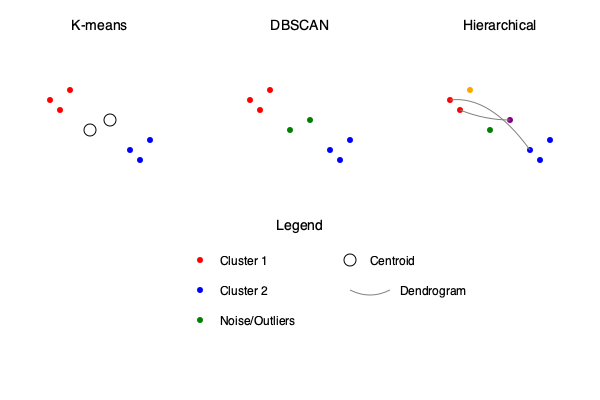Analyze the visual comparison of K-means, DBSCAN, and Hierarchical clustering algorithms on scattered data points. Which algorithm is most suitable for identifying clusters of arbitrary shape and handling noise in the dataset? To determine the most suitable algorithm for identifying clusters of arbitrary shape and handling noise, let's analyze each algorithm's characteristics based on the visual representation:

1. K-means:
   - Assumes spherical clusters
   - Sensitive to outliers
   - Requires predefined number of clusters
   - Centroids (black circles) are shown
   - Unable to identify noise points

2. DBSCAN (Density-Based Spatial Clustering of Applications with Noise):
   - Can identify clusters of arbitrary shape
   - Robust to outliers
   - Doesn't require predefined number of clusters
   - Identifies noise points (green)
   - Density-based approach

3. Hierarchical Clustering:
   - Can identify clusters of varying shapes
   - Sensitive to outliers
   - Doesn't require predefined number of clusters
   - Shows hierarchical structure (dendrogram)
   - May create small or singleton clusters

DBSCAN is the most suitable algorithm for identifying clusters of arbitrary shape and handling noise because:
1. It can detect clusters of any shape, not just spherical ones like K-means.
2. It explicitly identifies noise points (green in the diagram), which neither K-means nor Hierarchical clustering do.
3. It doesn't require a predefined number of clusters, allowing it to adapt to the data's natural structure.
4. It's robust to outliers, as it considers them as noise rather than forcing them into clusters.

The visual representation clearly shows DBSCAN's ability to identify the two main clusters (red and blue) while classifying the points in between as noise (green), which aligns with the scattered nature of the data points.
Answer: DBSCAN 